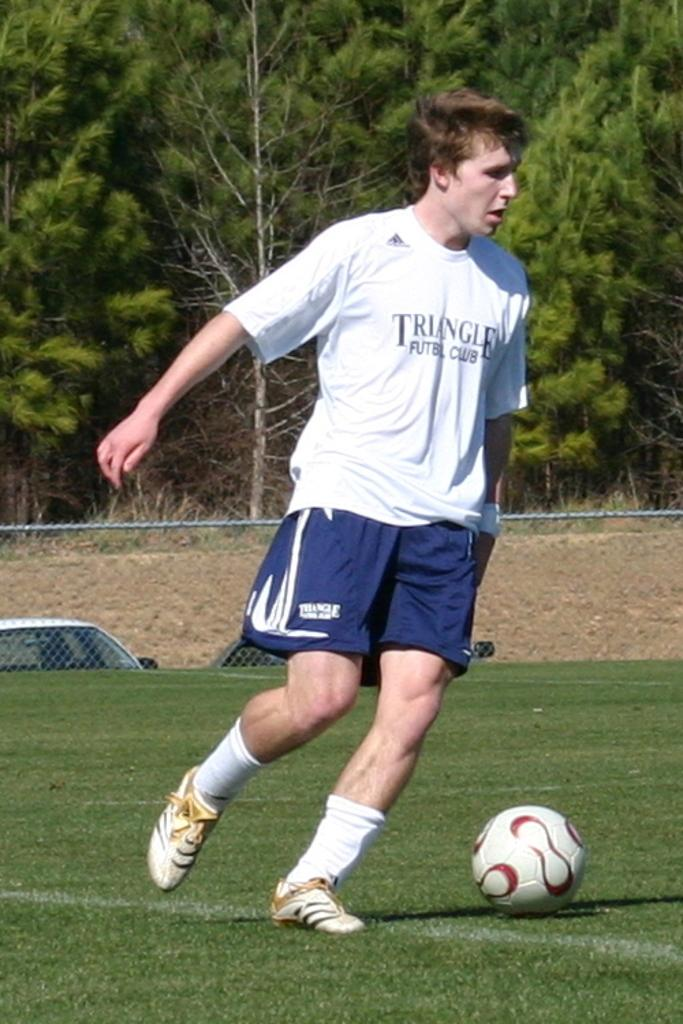<image>
Provide a brief description of the given image. A man playing soccer is kicking the ball and wearing a shirt that says Triangle. 